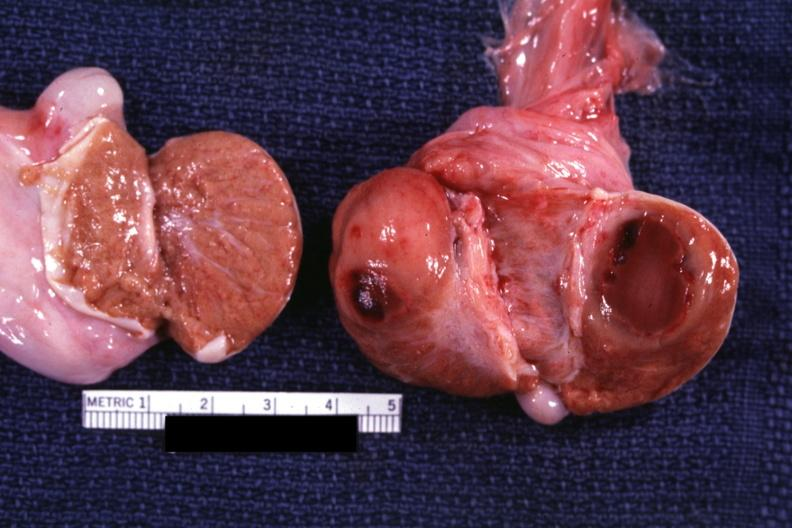does this image show cut surface with round tumor mass and large area central necrosis chronic granulocytic leukemia?
Answer the question using a single word or phrase. Yes 